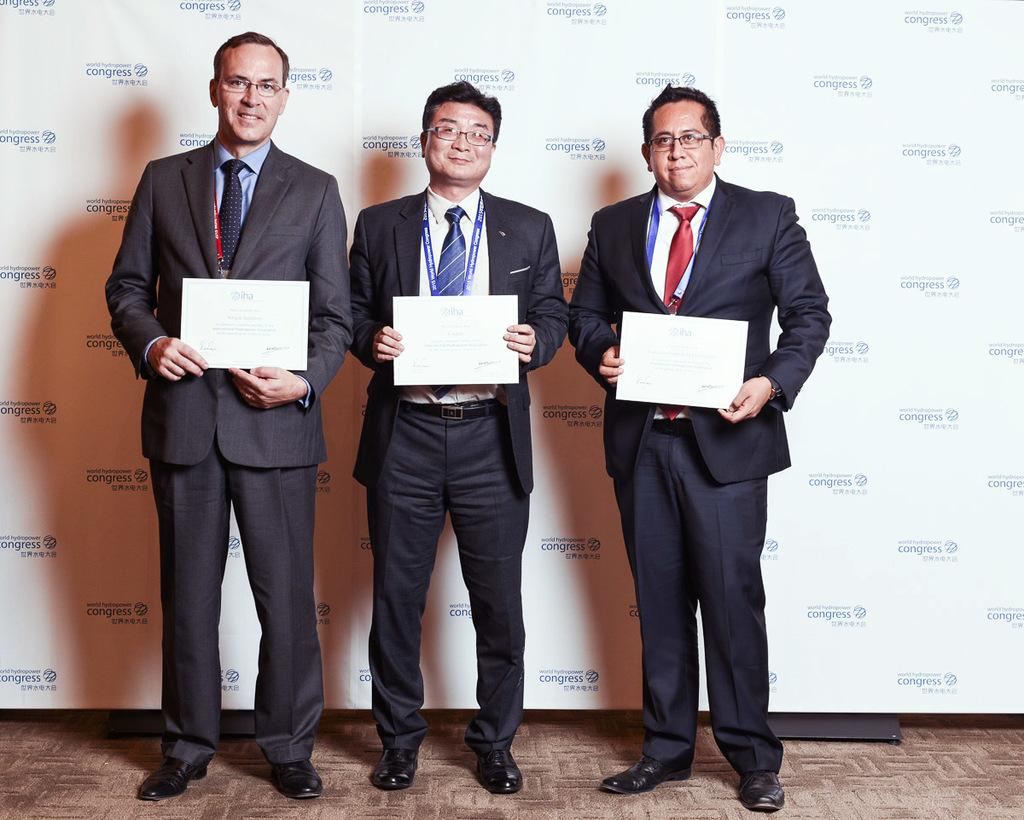How many people are in the image? There are three men in the image. What are the men doing in the image? The men are standing in the image. What are the men holding in the image? The men are holding certificates in the image. What are the men wearing in the image? The men are wearing spectacles in the image. What can be seen in the background of the image? There is a banner with text in the background of the image. What color is the sweater worn by the man on the right in the image? There is no sweater mentioned in the facts provided, and the man on the right is not described as wearing a sweater. What type of paste is being used by the men in the image? There is no mention of paste in the image or the facts provided. 